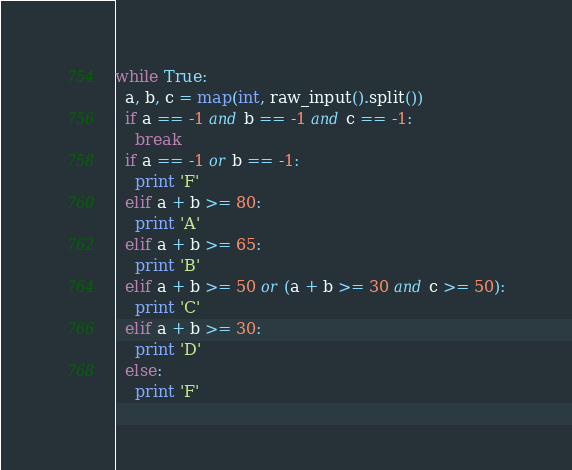Convert code to text. <code><loc_0><loc_0><loc_500><loc_500><_Python_>while True:
  a, b, c = map(int, raw_input().split())
  if a == -1 and b == -1 and c == -1:
    break
  if a == -1 or b == -1:
    print 'F'
  elif a + b >= 80:
    print 'A'
  elif a + b >= 65:
    print 'B'
  elif a + b >= 50 or (a + b >= 30 and c >= 50):
    print 'C'
  elif a + b >= 30:
    print 'D'
  else:
    print 'F'</code> 